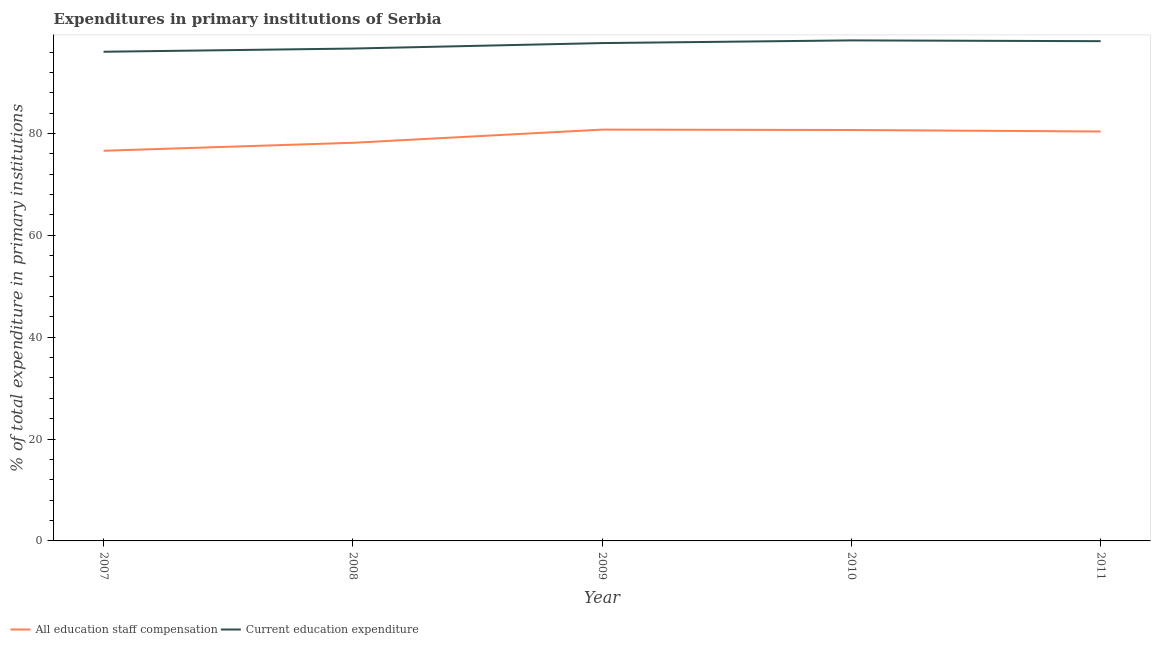Does the line corresponding to expenditure in staff compensation intersect with the line corresponding to expenditure in education?
Your answer should be very brief. No. Is the number of lines equal to the number of legend labels?
Your answer should be very brief. Yes. What is the expenditure in education in 2010?
Provide a short and direct response. 98.28. Across all years, what is the maximum expenditure in education?
Keep it short and to the point. 98.28. Across all years, what is the minimum expenditure in staff compensation?
Provide a short and direct response. 76.61. In which year was the expenditure in education maximum?
Offer a very short reply. 2010. What is the total expenditure in staff compensation in the graph?
Provide a short and direct response. 396.63. What is the difference between the expenditure in education in 2009 and that in 2011?
Provide a succinct answer. -0.37. What is the difference between the expenditure in staff compensation in 2007 and the expenditure in education in 2008?
Your answer should be very brief. -20.07. What is the average expenditure in staff compensation per year?
Your answer should be compact. 79.33. In the year 2008, what is the difference between the expenditure in staff compensation and expenditure in education?
Give a very brief answer. -18.5. What is the ratio of the expenditure in staff compensation in 2008 to that in 2011?
Your answer should be compact. 0.97. Is the expenditure in education in 2007 less than that in 2010?
Provide a succinct answer. Yes. What is the difference between the highest and the second highest expenditure in education?
Keep it short and to the point. 0.15. What is the difference between the highest and the lowest expenditure in staff compensation?
Provide a succinct answer. 4.15. Is the sum of the expenditure in staff compensation in 2008 and 2010 greater than the maximum expenditure in education across all years?
Your answer should be very brief. Yes. How many years are there in the graph?
Make the answer very short. 5. What is the difference between two consecutive major ticks on the Y-axis?
Your response must be concise. 20. Does the graph contain any zero values?
Your response must be concise. No. Does the graph contain grids?
Make the answer very short. No. How are the legend labels stacked?
Provide a short and direct response. Horizontal. What is the title of the graph?
Give a very brief answer. Expenditures in primary institutions of Serbia. What is the label or title of the X-axis?
Provide a succinct answer. Year. What is the label or title of the Y-axis?
Offer a terse response. % of total expenditure in primary institutions. What is the % of total expenditure in primary institutions in All education staff compensation in 2007?
Make the answer very short. 76.61. What is the % of total expenditure in primary institutions in Current education expenditure in 2007?
Give a very brief answer. 96.05. What is the % of total expenditure in primary institutions in All education staff compensation in 2008?
Offer a very short reply. 78.18. What is the % of total expenditure in primary institutions in Current education expenditure in 2008?
Ensure brevity in your answer.  96.68. What is the % of total expenditure in primary institutions of All education staff compensation in 2009?
Your answer should be very brief. 80.76. What is the % of total expenditure in primary institutions of Current education expenditure in 2009?
Your answer should be very brief. 97.76. What is the % of total expenditure in primary institutions in All education staff compensation in 2010?
Your response must be concise. 80.69. What is the % of total expenditure in primary institutions of Current education expenditure in 2010?
Your answer should be compact. 98.28. What is the % of total expenditure in primary institutions in All education staff compensation in 2011?
Provide a succinct answer. 80.39. What is the % of total expenditure in primary institutions of Current education expenditure in 2011?
Make the answer very short. 98.13. Across all years, what is the maximum % of total expenditure in primary institutions in All education staff compensation?
Give a very brief answer. 80.76. Across all years, what is the maximum % of total expenditure in primary institutions of Current education expenditure?
Provide a short and direct response. 98.28. Across all years, what is the minimum % of total expenditure in primary institutions in All education staff compensation?
Make the answer very short. 76.61. Across all years, what is the minimum % of total expenditure in primary institutions in Current education expenditure?
Give a very brief answer. 96.05. What is the total % of total expenditure in primary institutions of All education staff compensation in the graph?
Ensure brevity in your answer.  396.63. What is the total % of total expenditure in primary institutions in Current education expenditure in the graph?
Offer a terse response. 486.9. What is the difference between the % of total expenditure in primary institutions of All education staff compensation in 2007 and that in 2008?
Make the answer very short. -1.56. What is the difference between the % of total expenditure in primary institutions in Current education expenditure in 2007 and that in 2008?
Keep it short and to the point. -0.63. What is the difference between the % of total expenditure in primary institutions in All education staff compensation in 2007 and that in 2009?
Offer a terse response. -4.15. What is the difference between the % of total expenditure in primary institutions in Current education expenditure in 2007 and that in 2009?
Offer a terse response. -1.7. What is the difference between the % of total expenditure in primary institutions of All education staff compensation in 2007 and that in 2010?
Provide a short and direct response. -4.07. What is the difference between the % of total expenditure in primary institutions of Current education expenditure in 2007 and that in 2010?
Your answer should be very brief. -2.23. What is the difference between the % of total expenditure in primary institutions in All education staff compensation in 2007 and that in 2011?
Ensure brevity in your answer.  -3.78. What is the difference between the % of total expenditure in primary institutions of Current education expenditure in 2007 and that in 2011?
Keep it short and to the point. -2.08. What is the difference between the % of total expenditure in primary institutions of All education staff compensation in 2008 and that in 2009?
Keep it short and to the point. -2.59. What is the difference between the % of total expenditure in primary institutions of Current education expenditure in 2008 and that in 2009?
Your answer should be very brief. -1.08. What is the difference between the % of total expenditure in primary institutions of All education staff compensation in 2008 and that in 2010?
Provide a succinct answer. -2.51. What is the difference between the % of total expenditure in primary institutions of Current education expenditure in 2008 and that in 2010?
Ensure brevity in your answer.  -1.6. What is the difference between the % of total expenditure in primary institutions in All education staff compensation in 2008 and that in 2011?
Offer a very short reply. -2.22. What is the difference between the % of total expenditure in primary institutions of Current education expenditure in 2008 and that in 2011?
Offer a very short reply. -1.45. What is the difference between the % of total expenditure in primary institutions in All education staff compensation in 2009 and that in 2010?
Your answer should be very brief. 0.08. What is the difference between the % of total expenditure in primary institutions of Current education expenditure in 2009 and that in 2010?
Keep it short and to the point. -0.53. What is the difference between the % of total expenditure in primary institutions of All education staff compensation in 2009 and that in 2011?
Ensure brevity in your answer.  0.37. What is the difference between the % of total expenditure in primary institutions in Current education expenditure in 2009 and that in 2011?
Your answer should be compact. -0.37. What is the difference between the % of total expenditure in primary institutions in All education staff compensation in 2010 and that in 2011?
Your response must be concise. 0.29. What is the difference between the % of total expenditure in primary institutions of Current education expenditure in 2010 and that in 2011?
Make the answer very short. 0.15. What is the difference between the % of total expenditure in primary institutions of All education staff compensation in 2007 and the % of total expenditure in primary institutions of Current education expenditure in 2008?
Make the answer very short. -20.07. What is the difference between the % of total expenditure in primary institutions of All education staff compensation in 2007 and the % of total expenditure in primary institutions of Current education expenditure in 2009?
Make the answer very short. -21.14. What is the difference between the % of total expenditure in primary institutions of All education staff compensation in 2007 and the % of total expenditure in primary institutions of Current education expenditure in 2010?
Your answer should be very brief. -21.67. What is the difference between the % of total expenditure in primary institutions in All education staff compensation in 2007 and the % of total expenditure in primary institutions in Current education expenditure in 2011?
Offer a terse response. -21.52. What is the difference between the % of total expenditure in primary institutions in All education staff compensation in 2008 and the % of total expenditure in primary institutions in Current education expenditure in 2009?
Offer a very short reply. -19.58. What is the difference between the % of total expenditure in primary institutions of All education staff compensation in 2008 and the % of total expenditure in primary institutions of Current education expenditure in 2010?
Your answer should be very brief. -20.11. What is the difference between the % of total expenditure in primary institutions of All education staff compensation in 2008 and the % of total expenditure in primary institutions of Current education expenditure in 2011?
Your response must be concise. -19.95. What is the difference between the % of total expenditure in primary institutions of All education staff compensation in 2009 and the % of total expenditure in primary institutions of Current education expenditure in 2010?
Your answer should be compact. -17.52. What is the difference between the % of total expenditure in primary institutions of All education staff compensation in 2009 and the % of total expenditure in primary institutions of Current education expenditure in 2011?
Your answer should be compact. -17.37. What is the difference between the % of total expenditure in primary institutions of All education staff compensation in 2010 and the % of total expenditure in primary institutions of Current education expenditure in 2011?
Keep it short and to the point. -17.44. What is the average % of total expenditure in primary institutions in All education staff compensation per year?
Give a very brief answer. 79.33. What is the average % of total expenditure in primary institutions of Current education expenditure per year?
Your response must be concise. 97.38. In the year 2007, what is the difference between the % of total expenditure in primary institutions of All education staff compensation and % of total expenditure in primary institutions of Current education expenditure?
Your response must be concise. -19.44. In the year 2008, what is the difference between the % of total expenditure in primary institutions in All education staff compensation and % of total expenditure in primary institutions in Current education expenditure?
Give a very brief answer. -18.5. In the year 2009, what is the difference between the % of total expenditure in primary institutions of All education staff compensation and % of total expenditure in primary institutions of Current education expenditure?
Your response must be concise. -16.99. In the year 2010, what is the difference between the % of total expenditure in primary institutions in All education staff compensation and % of total expenditure in primary institutions in Current education expenditure?
Make the answer very short. -17.6. In the year 2011, what is the difference between the % of total expenditure in primary institutions of All education staff compensation and % of total expenditure in primary institutions of Current education expenditure?
Keep it short and to the point. -17.74. What is the ratio of the % of total expenditure in primary institutions in All education staff compensation in 2007 to that in 2008?
Your response must be concise. 0.98. What is the ratio of the % of total expenditure in primary institutions in All education staff compensation in 2007 to that in 2009?
Your answer should be very brief. 0.95. What is the ratio of the % of total expenditure in primary institutions in Current education expenditure in 2007 to that in 2009?
Provide a succinct answer. 0.98. What is the ratio of the % of total expenditure in primary institutions of All education staff compensation in 2007 to that in 2010?
Your answer should be very brief. 0.95. What is the ratio of the % of total expenditure in primary institutions of Current education expenditure in 2007 to that in 2010?
Provide a short and direct response. 0.98. What is the ratio of the % of total expenditure in primary institutions in All education staff compensation in 2007 to that in 2011?
Keep it short and to the point. 0.95. What is the ratio of the % of total expenditure in primary institutions in Current education expenditure in 2007 to that in 2011?
Your response must be concise. 0.98. What is the ratio of the % of total expenditure in primary institutions in All education staff compensation in 2008 to that in 2010?
Provide a short and direct response. 0.97. What is the ratio of the % of total expenditure in primary institutions of Current education expenditure in 2008 to that in 2010?
Your response must be concise. 0.98. What is the ratio of the % of total expenditure in primary institutions in All education staff compensation in 2008 to that in 2011?
Provide a short and direct response. 0.97. What is the ratio of the % of total expenditure in primary institutions of Current education expenditure in 2008 to that in 2011?
Provide a succinct answer. 0.99. What is the ratio of the % of total expenditure in primary institutions in Current education expenditure in 2009 to that in 2010?
Make the answer very short. 0.99. What is the ratio of the % of total expenditure in primary institutions in All education staff compensation in 2009 to that in 2011?
Your answer should be very brief. 1. What is the ratio of the % of total expenditure in primary institutions of Current education expenditure in 2010 to that in 2011?
Offer a very short reply. 1. What is the difference between the highest and the second highest % of total expenditure in primary institutions of All education staff compensation?
Provide a succinct answer. 0.08. What is the difference between the highest and the second highest % of total expenditure in primary institutions in Current education expenditure?
Your response must be concise. 0.15. What is the difference between the highest and the lowest % of total expenditure in primary institutions in All education staff compensation?
Offer a very short reply. 4.15. What is the difference between the highest and the lowest % of total expenditure in primary institutions in Current education expenditure?
Keep it short and to the point. 2.23. 